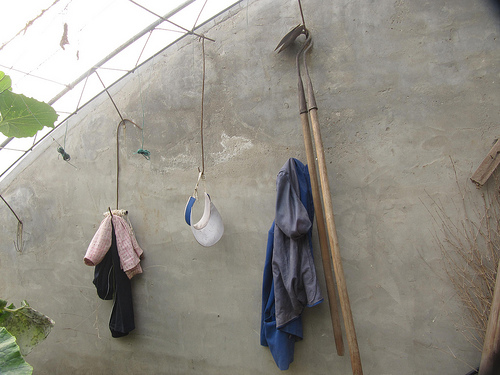<image>
Can you confirm if the hoe is on the hook? Yes. Looking at the image, I can see the hoe is positioned on top of the hook, with the hook providing support. Where is the garden hoe in relation to the wire? Is it on the wire? Yes. Looking at the image, I can see the garden hoe is positioned on top of the wire, with the wire providing support. Is there a hoe to the right of the visor? Yes. From this viewpoint, the hoe is positioned to the right side relative to the visor. 